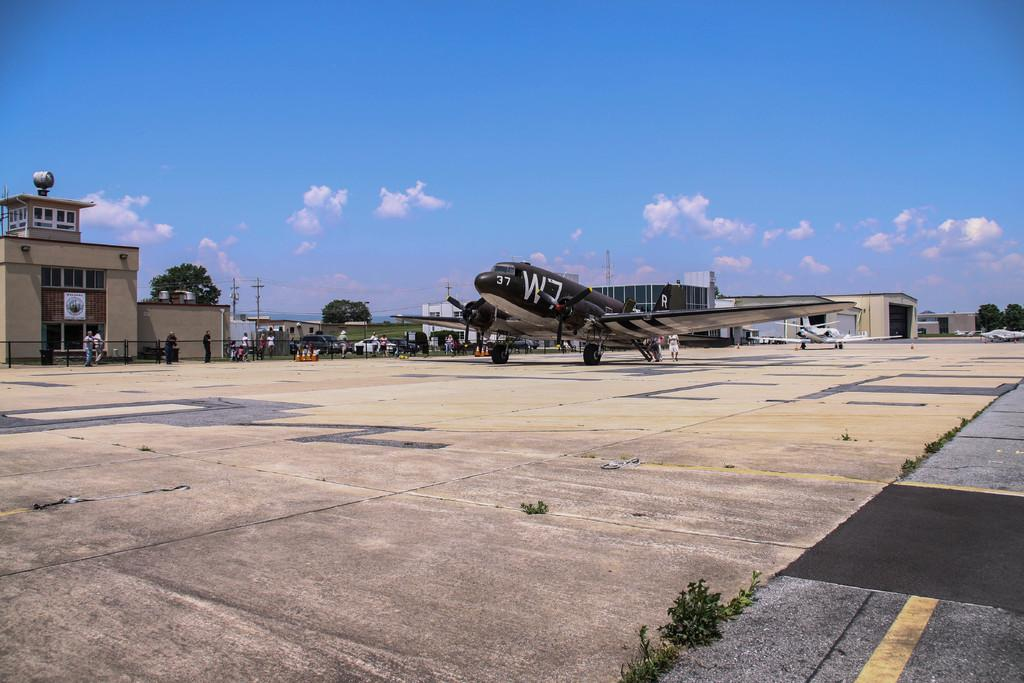<image>
Offer a succinct explanation of the picture presented. An old black plane on a tarmac has 37 and W7 painted on its fuselage. 